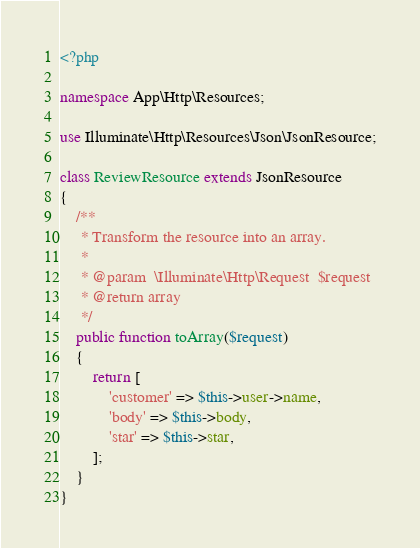<code> <loc_0><loc_0><loc_500><loc_500><_PHP_><?php

namespace App\Http\Resources;

use Illuminate\Http\Resources\Json\JsonResource;

class ReviewResource extends JsonResource
{
    /**
     * Transform the resource into an array.
     *
     * @param  \Illuminate\Http\Request  $request
     * @return array
     */
    public function toArray($request)
    {
        return [
            'customer' => $this->user->name,
            'body' => $this->body,
            'star' => $this->star,
        ];
    }
}
</code> 